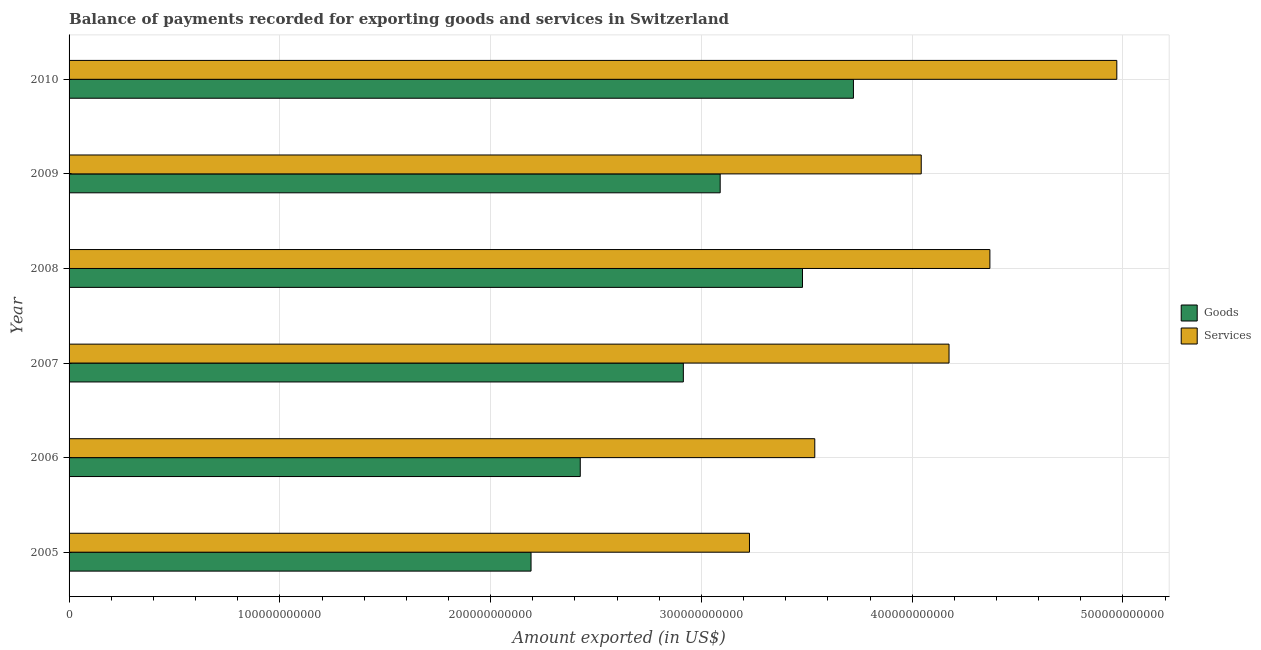How many groups of bars are there?
Your answer should be compact. 6. Are the number of bars per tick equal to the number of legend labels?
Offer a terse response. Yes. Are the number of bars on each tick of the Y-axis equal?
Offer a very short reply. Yes. How many bars are there on the 6th tick from the top?
Your answer should be compact. 2. What is the label of the 4th group of bars from the top?
Provide a succinct answer. 2007. In how many cases, is the number of bars for a given year not equal to the number of legend labels?
Give a very brief answer. 0. What is the amount of goods exported in 2010?
Offer a terse response. 3.72e+11. Across all years, what is the maximum amount of services exported?
Keep it short and to the point. 4.97e+11. Across all years, what is the minimum amount of goods exported?
Offer a very short reply. 2.19e+11. In which year was the amount of services exported maximum?
Provide a short and direct response. 2010. In which year was the amount of services exported minimum?
Provide a succinct answer. 2005. What is the total amount of services exported in the graph?
Your answer should be very brief. 2.43e+12. What is the difference between the amount of goods exported in 2009 and that in 2010?
Your response must be concise. -6.32e+1. What is the difference between the amount of services exported in 2010 and the amount of goods exported in 2007?
Keep it short and to the point. 2.06e+11. What is the average amount of goods exported per year?
Make the answer very short. 2.97e+11. In the year 2007, what is the difference between the amount of goods exported and amount of services exported?
Your answer should be very brief. -1.26e+11. What is the ratio of the amount of services exported in 2008 to that in 2009?
Ensure brevity in your answer.  1.08. Is the difference between the amount of services exported in 2005 and 2006 greater than the difference between the amount of goods exported in 2005 and 2006?
Make the answer very short. No. What is the difference between the highest and the second highest amount of services exported?
Offer a very short reply. 6.02e+1. What is the difference between the highest and the lowest amount of services exported?
Ensure brevity in your answer.  1.74e+11. What does the 1st bar from the top in 2007 represents?
Ensure brevity in your answer.  Services. What does the 1st bar from the bottom in 2007 represents?
Your response must be concise. Goods. How many bars are there?
Offer a very short reply. 12. Are all the bars in the graph horizontal?
Offer a terse response. Yes. How many years are there in the graph?
Provide a succinct answer. 6. What is the difference between two consecutive major ticks on the X-axis?
Your answer should be compact. 1.00e+11. Are the values on the major ticks of X-axis written in scientific E-notation?
Your answer should be very brief. No. Does the graph contain any zero values?
Provide a short and direct response. No. Does the graph contain grids?
Keep it short and to the point. Yes. Where does the legend appear in the graph?
Offer a terse response. Center right. How are the legend labels stacked?
Ensure brevity in your answer.  Vertical. What is the title of the graph?
Offer a very short reply. Balance of payments recorded for exporting goods and services in Switzerland. What is the label or title of the X-axis?
Make the answer very short. Amount exported (in US$). What is the Amount exported (in US$) in Goods in 2005?
Ensure brevity in your answer.  2.19e+11. What is the Amount exported (in US$) in Services in 2005?
Ensure brevity in your answer.  3.23e+11. What is the Amount exported (in US$) in Goods in 2006?
Offer a very short reply. 2.43e+11. What is the Amount exported (in US$) of Services in 2006?
Offer a terse response. 3.54e+11. What is the Amount exported (in US$) of Goods in 2007?
Offer a very short reply. 2.91e+11. What is the Amount exported (in US$) in Services in 2007?
Ensure brevity in your answer.  4.17e+11. What is the Amount exported (in US$) in Goods in 2008?
Ensure brevity in your answer.  3.48e+11. What is the Amount exported (in US$) in Services in 2008?
Ensure brevity in your answer.  4.37e+11. What is the Amount exported (in US$) of Goods in 2009?
Your answer should be compact. 3.09e+11. What is the Amount exported (in US$) in Services in 2009?
Your response must be concise. 4.04e+11. What is the Amount exported (in US$) in Goods in 2010?
Your response must be concise. 3.72e+11. What is the Amount exported (in US$) of Services in 2010?
Keep it short and to the point. 4.97e+11. Across all years, what is the maximum Amount exported (in US$) in Goods?
Your answer should be compact. 3.72e+11. Across all years, what is the maximum Amount exported (in US$) of Services?
Offer a terse response. 4.97e+11. Across all years, what is the minimum Amount exported (in US$) of Goods?
Give a very brief answer. 2.19e+11. Across all years, what is the minimum Amount exported (in US$) of Services?
Provide a short and direct response. 3.23e+11. What is the total Amount exported (in US$) of Goods in the graph?
Offer a terse response. 1.78e+12. What is the total Amount exported (in US$) of Services in the graph?
Provide a short and direct response. 2.43e+12. What is the difference between the Amount exported (in US$) in Goods in 2005 and that in 2006?
Offer a terse response. -2.34e+1. What is the difference between the Amount exported (in US$) of Services in 2005 and that in 2006?
Provide a short and direct response. -3.10e+1. What is the difference between the Amount exported (in US$) of Goods in 2005 and that in 2007?
Make the answer very short. -7.23e+1. What is the difference between the Amount exported (in US$) in Services in 2005 and that in 2007?
Offer a terse response. -9.47e+1. What is the difference between the Amount exported (in US$) in Goods in 2005 and that in 2008?
Provide a short and direct response. -1.29e+11. What is the difference between the Amount exported (in US$) of Services in 2005 and that in 2008?
Your response must be concise. -1.14e+11. What is the difference between the Amount exported (in US$) in Goods in 2005 and that in 2009?
Offer a terse response. -8.97e+1. What is the difference between the Amount exported (in US$) in Services in 2005 and that in 2009?
Make the answer very short. -8.15e+1. What is the difference between the Amount exported (in US$) in Goods in 2005 and that in 2010?
Make the answer very short. -1.53e+11. What is the difference between the Amount exported (in US$) of Services in 2005 and that in 2010?
Offer a terse response. -1.74e+11. What is the difference between the Amount exported (in US$) of Goods in 2006 and that in 2007?
Give a very brief answer. -4.89e+1. What is the difference between the Amount exported (in US$) in Services in 2006 and that in 2007?
Offer a very short reply. -6.37e+1. What is the difference between the Amount exported (in US$) in Goods in 2006 and that in 2008?
Ensure brevity in your answer.  -1.05e+11. What is the difference between the Amount exported (in US$) of Services in 2006 and that in 2008?
Make the answer very short. -8.31e+1. What is the difference between the Amount exported (in US$) in Goods in 2006 and that in 2009?
Provide a succinct answer. -6.64e+1. What is the difference between the Amount exported (in US$) of Services in 2006 and that in 2009?
Ensure brevity in your answer.  -5.05e+1. What is the difference between the Amount exported (in US$) of Goods in 2006 and that in 2010?
Provide a succinct answer. -1.30e+11. What is the difference between the Amount exported (in US$) of Services in 2006 and that in 2010?
Give a very brief answer. -1.43e+11. What is the difference between the Amount exported (in US$) in Goods in 2007 and that in 2008?
Offer a terse response. -5.65e+1. What is the difference between the Amount exported (in US$) of Services in 2007 and that in 2008?
Keep it short and to the point. -1.94e+1. What is the difference between the Amount exported (in US$) in Goods in 2007 and that in 2009?
Offer a very short reply. -1.75e+1. What is the difference between the Amount exported (in US$) of Services in 2007 and that in 2009?
Ensure brevity in your answer.  1.32e+1. What is the difference between the Amount exported (in US$) of Goods in 2007 and that in 2010?
Provide a succinct answer. -8.07e+1. What is the difference between the Amount exported (in US$) in Services in 2007 and that in 2010?
Keep it short and to the point. -7.96e+1. What is the difference between the Amount exported (in US$) of Goods in 2008 and that in 2009?
Offer a terse response. 3.91e+1. What is the difference between the Amount exported (in US$) of Services in 2008 and that in 2009?
Offer a terse response. 3.26e+1. What is the difference between the Amount exported (in US$) of Goods in 2008 and that in 2010?
Give a very brief answer. -2.42e+1. What is the difference between the Amount exported (in US$) in Services in 2008 and that in 2010?
Ensure brevity in your answer.  -6.02e+1. What is the difference between the Amount exported (in US$) of Goods in 2009 and that in 2010?
Make the answer very short. -6.32e+1. What is the difference between the Amount exported (in US$) in Services in 2009 and that in 2010?
Keep it short and to the point. -9.28e+1. What is the difference between the Amount exported (in US$) of Goods in 2005 and the Amount exported (in US$) of Services in 2006?
Ensure brevity in your answer.  -1.35e+11. What is the difference between the Amount exported (in US$) of Goods in 2005 and the Amount exported (in US$) of Services in 2007?
Offer a very short reply. -1.98e+11. What is the difference between the Amount exported (in US$) in Goods in 2005 and the Amount exported (in US$) in Services in 2008?
Offer a terse response. -2.18e+11. What is the difference between the Amount exported (in US$) in Goods in 2005 and the Amount exported (in US$) in Services in 2009?
Offer a very short reply. -1.85e+11. What is the difference between the Amount exported (in US$) in Goods in 2005 and the Amount exported (in US$) in Services in 2010?
Provide a short and direct response. -2.78e+11. What is the difference between the Amount exported (in US$) in Goods in 2006 and the Amount exported (in US$) in Services in 2007?
Offer a terse response. -1.75e+11. What is the difference between the Amount exported (in US$) in Goods in 2006 and the Amount exported (in US$) in Services in 2008?
Your response must be concise. -1.94e+11. What is the difference between the Amount exported (in US$) of Goods in 2006 and the Amount exported (in US$) of Services in 2009?
Your response must be concise. -1.62e+11. What is the difference between the Amount exported (in US$) of Goods in 2006 and the Amount exported (in US$) of Services in 2010?
Offer a very short reply. -2.55e+11. What is the difference between the Amount exported (in US$) of Goods in 2007 and the Amount exported (in US$) of Services in 2008?
Make the answer very short. -1.45e+11. What is the difference between the Amount exported (in US$) in Goods in 2007 and the Amount exported (in US$) in Services in 2009?
Make the answer very short. -1.13e+11. What is the difference between the Amount exported (in US$) in Goods in 2007 and the Amount exported (in US$) in Services in 2010?
Keep it short and to the point. -2.06e+11. What is the difference between the Amount exported (in US$) of Goods in 2008 and the Amount exported (in US$) of Services in 2009?
Your response must be concise. -5.63e+1. What is the difference between the Amount exported (in US$) of Goods in 2008 and the Amount exported (in US$) of Services in 2010?
Your response must be concise. -1.49e+11. What is the difference between the Amount exported (in US$) of Goods in 2009 and the Amount exported (in US$) of Services in 2010?
Keep it short and to the point. -1.88e+11. What is the average Amount exported (in US$) in Goods per year?
Give a very brief answer. 2.97e+11. What is the average Amount exported (in US$) of Services per year?
Provide a short and direct response. 4.05e+11. In the year 2005, what is the difference between the Amount exported (in US$) of Goods and Amount exported (in US$) of Services?
Make the answer very short. -1.04e+11. In the year 2006, what is the difference between the Amount exported (in US$) in Goods and Amount exported (in US$) in Services?
Your response must be concise. -1.11e+11. In the year 2007, what is the difference between the Amount exported (in US$) in Goods and Amount exported (in US$) in Services?
Keep it short and to the point. -1.26e+11. In the year 2008, what is the difference between the Amount exported (in US$) of Goods and Amount exported (in US$) of Services?
Ensure brevity in your answer.  -8.89e+1. In the year 2009, what is the difference between the Amount exported (in US$) in Goods and Amount exported (in US$) in Services?
Ensure brevity in your answer.  -9.54e+1. In the year 2010, what is the difference between the Amount exported (in US$) in Goods and Amount exported (in US$) in Services?
Provide a short and direct response. -1.25e+11. What is the ratio of the Amount exported (in US$) of Goods in 2005 to that in 2006?
Offer a very short reply. 0.9. What is the ratio of the Amount exported (in US$) of Services in 2005 to that in 2006?
Your response must be concise. 0.91. What is the ratio of the Amount exported (in US$) of Goods in 2005 to that in 2007?
Ensure brevity in your answer.  0.75. What is the ratio of the Amount exported (in US$) of Services in 2005 to that in 2007?
Offer a very short reply. 0.77. What is the ratio of the Amount exported (in US$) of Goods in 2005 to that in 2008?
Ensure brevity in your answer.  0.63. What is the ratio of the Amount exported (in US$) of Services in 2005 to that in 2008?
Provide a short and direct response. 0.74. What is the ratio of the Amount exported (in US$) of Goods in 2005 to that in 2009?
Make the answer very short. 0.71. What is the ratio of the Amount exported (in US$) of Services in 2005 to that in 2009?
Provide a short and direct response. 0.8. What is the ratio of the Amount exported (in US$) of Goods in 2005 to that in 2010?
Your response must be concise. 0.59. What is the ratio of the Amount exported (in US$) of Services in 2005 to that in 2010?
Provide a short and direct response. 0.65. What is the ratio of the Amount exported (in US$) of Goods in 2006 to that in 2007?
Keep it short and to the point. 0.83. What is the ratio of the Amount exported (in US$) in Services in 2006 to that in 2007?
Keep it short and to the point. 0.85. What is the ratio of the Amount exported (in US$) of Goods in 2006 to that in 2008?
Your answer should be very brief. 0.7. What is the ratio of the Amount exported (in US$) in Services in 2006 to that in 2008?
Your response must be concise. 0.81. What is the ratio of the Amount exported (in US$) of Goods in 2006 to that in 2009?
Provide a succinct answer. 0.79. What is the ratio of the Amount exported (in US$) of Services in 2006 to that in 2009?
Provide a succinct answer. 0.88. What is the ratio of the Amount exported (in US$) in Goods in 2006 to that in 2010?
Offer a very short reply. 0.65. What is the ratio of the Amount exported (in US$) of Services in 2006 to that in 2010?
Ensure brevity in your answer.  0.71. What is the ratio of the Amount exported (in US$) in Goods in 2007 to that in 2008?
Your response must be concise. 0.84. What is the ratio of the Amount exported (in US$) of Services in 2007 to that in 2008?
Give a very brief answer. 0.96. What is the ratio of the Amount exported (in US$) of Goods in 2007 to that in 2009?
Provide a succinct answer. 0.94. What is the ratio of the Amount exported (in US$) in Services in 2007 to that in 2009?
Your response must be concise. 1.03. What is the ratio of the Amount exported (in US$) of Goods in 2007 to that in 2010?
Offer a very short reply. 0.78. What is the ratio of the Amount exported (in US$) of Services in 2007 to that in 2010?
Provide a short and direct response. 0.84. What is the ratio of the Amount exported (in US$) of Goods in 2008 to that in 2009?
Your response must be concise. 1.13. What is the ratio of the Amount exported (in US$) of Services in 2008 to that in 2009?
Keep it short and to the point. 1.08. What is the ratio of the Amount exported (in US$) of Goods in 2008 to that in 2010?
Your response must be concise. 0.94. What is the ratio of the Amount exported (in US$) in Services in 2008 to that in 2010?
Ensure brevity in your answer.  0.88. What is the ratio of the Amount exported (in US$) of Goods in 2009 to that in 2010?
Make the answer very short. 0.83. What is the ratio of the Amount exported (in US$) of Services in 2009 to that in 2010?
Keep it short and to the point. 0.81. What is the difference between the highest and the second highest Amount exported (in US$) in Goods?
Offer a very short reply. 2.42e+1. What is the difference between the highest and the second highest Amount exported (in US$) in Services?
Offer a very short reply. 6.02e+1. What is the difference between the highest and the lowest Amount exported (in US$) in Goods?
Provide a short and direct response. 1.53e+11. What is the difference between the highest and the lowest Amount exported (in US$) of Services?
Give a very brief answer. 1.74e+11. 